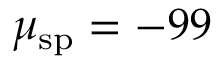<formula> <loc_0><loc_0><loc_500><loc_500>\mu _ { s p } = - 9 9</formula> 